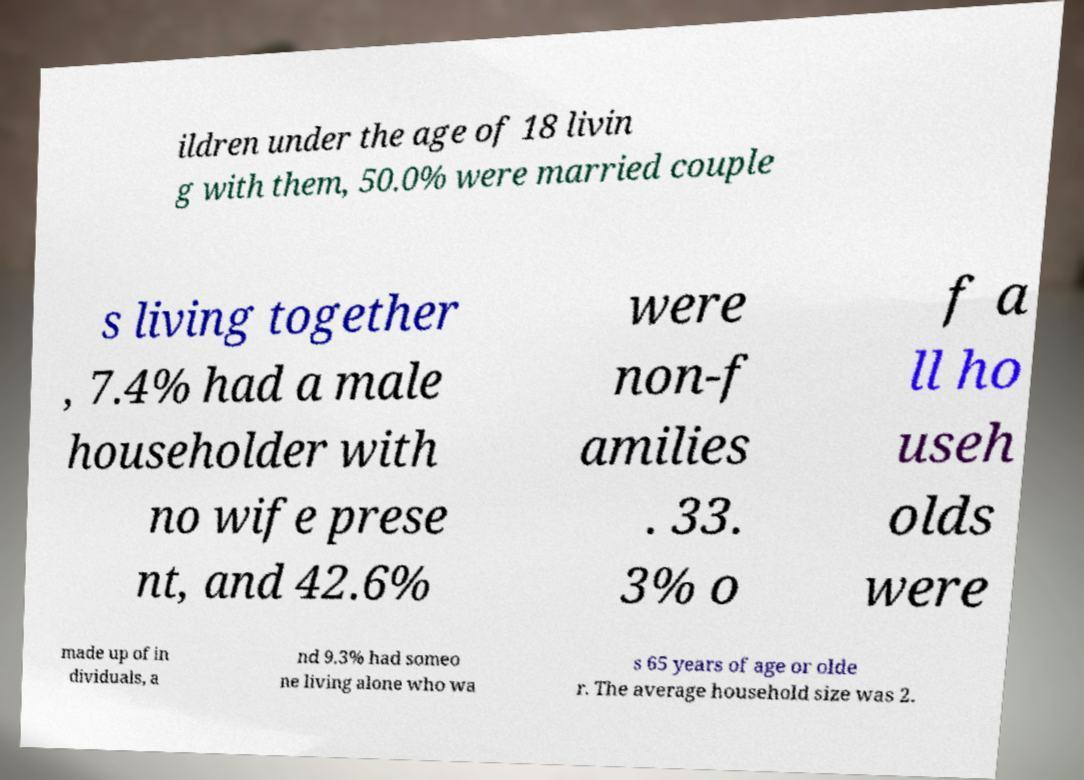For documentation purposes, I need the text within this image transcribed. Could you provide that? ildren under the age of 18 livin g with them, 50.0% were married couple s living together , 7.4% had a male householder with no wife prese nt, and 42.6% were non-f amilies . 33. 3% o f a ll ho useh olds were made up of in dividuals, a nd 9.3% had someo ne living alone who wa s 65 years of age or olde r. The average household size was 2. 